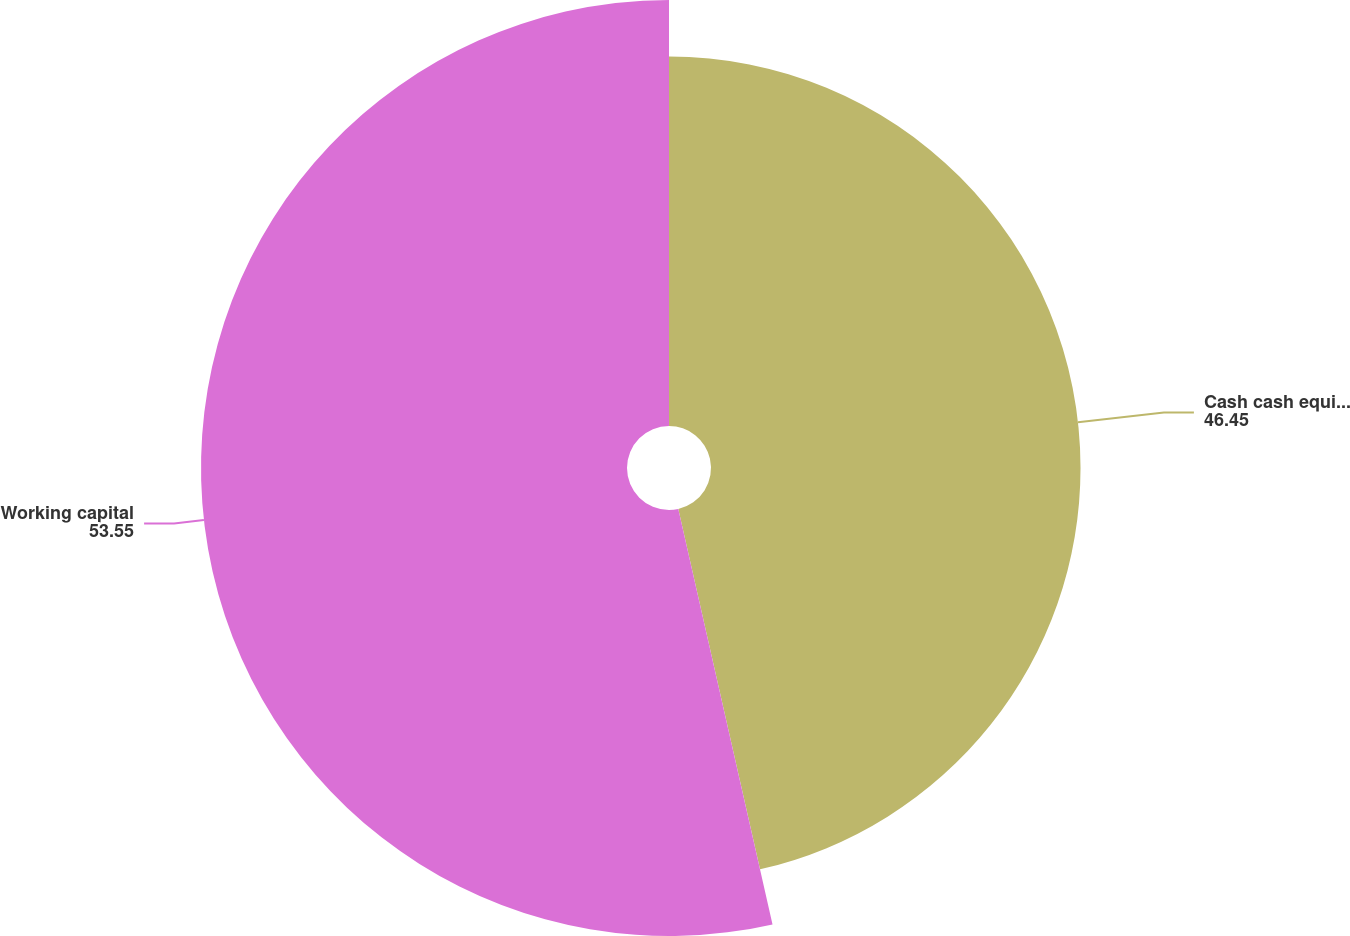<chart> <loc_0><loc_0><loc_500><loc_500><pie_chart><fcel>Cash cash equivalents and<fcel>Working capital<nl><fcel>46.45%<fcel>53.55%<nl></chart> 